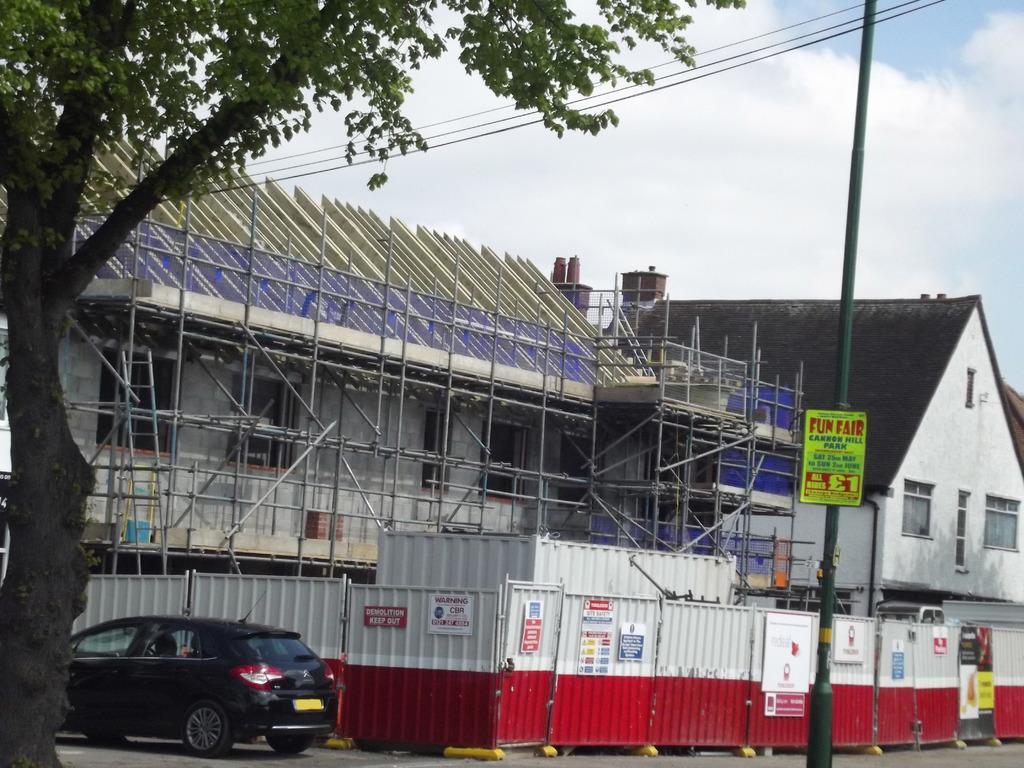Could you give a brief overview of what you see in this image? In this image I can see buildings, fence, poles among them this pole has a board attached to it and vehicle on the road. I can also see a tree and some other objects on the ground. In the background I can see the sky. 